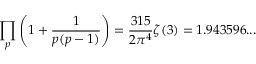<formula> <loc_0><loc_0><loc_500><loc_500>\prod _ { p } \left ( 1 + { \frac { 1 } { p ( p - 1 ) } } \right ) = { \frac { 3 1 5 } { 2 \pi ^ { 4 } } } \zeta ( 3 ) = 1 . 9 4 3 5 9 6 \dots</formula> 